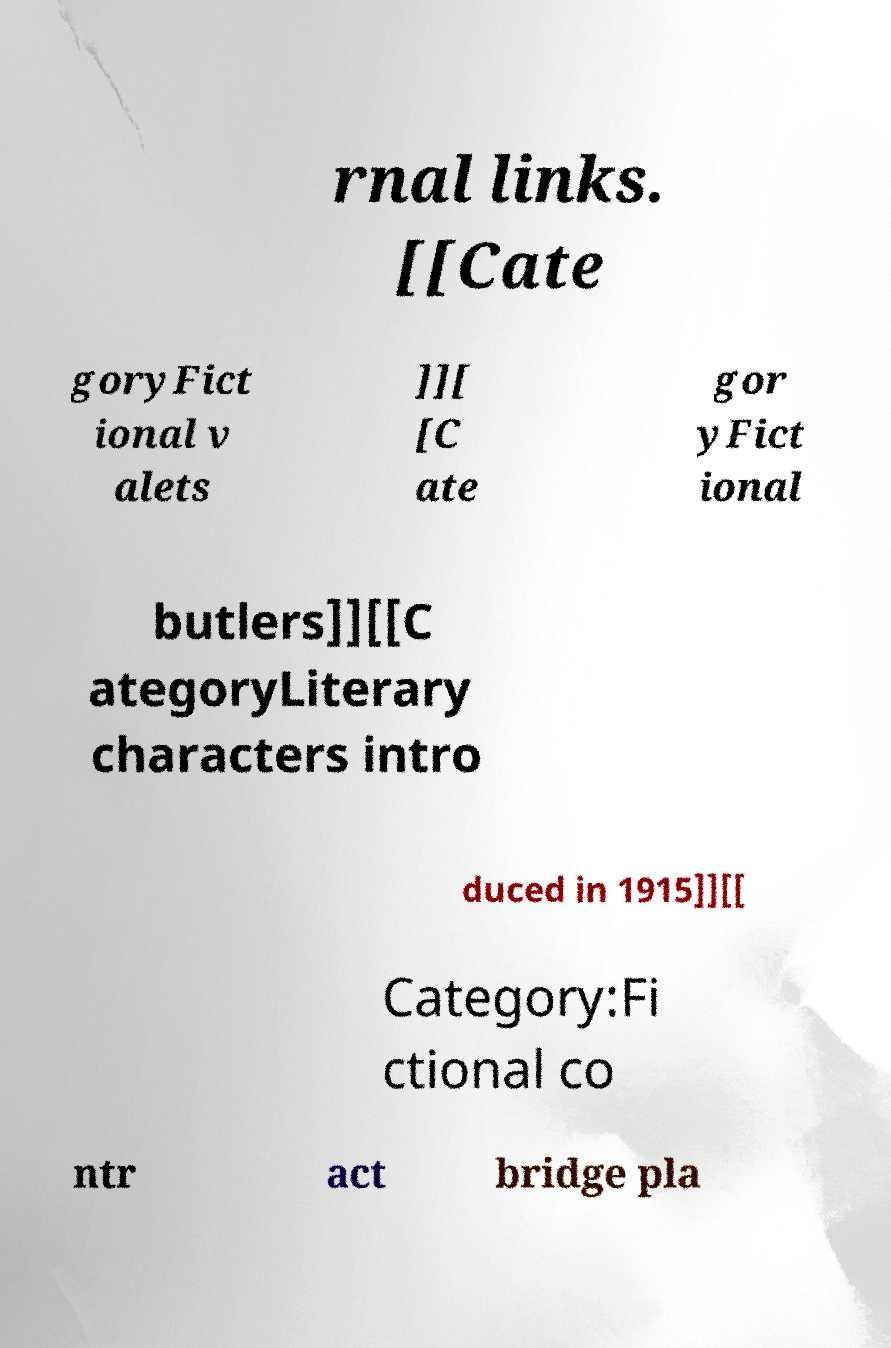There's text embedded in this image that I need extracted. Can you transcribe it verbatim? rnal links. [[Cate goryFict ional v alets ]][ [C ate gor yFict ional butlers]][[C ategoryLiterary characters intro duced in 1915]][[ Category:Fi ctional co ntr act bridge pla 